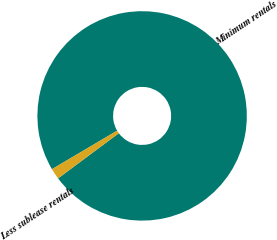Convert chart. <chart><loc_0><loc_0><loc_500><loc_500><pie_chart><fcel>Minimum rentals<fcel>Less sublease rentals<nl><fcel>98.32%<fcel>1.68%<nl></chart> 